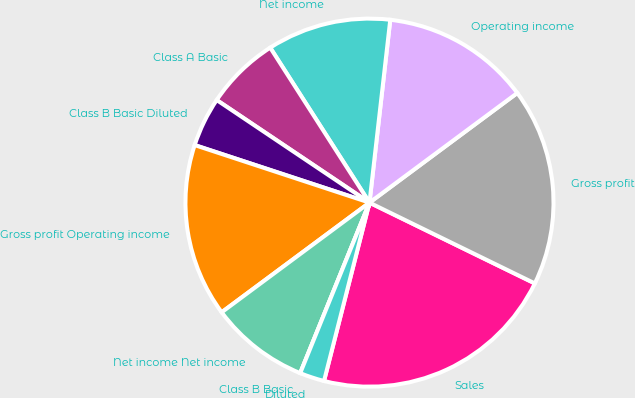Convert chart to OTSL. <chart><loc_0><loc_0><loc_500><loc_500><pie_chart><fcel>Sales<fcel>Gross profit<fcel>Operating income<fcel>Net income<fcel>Class A Basic<fcel>Class B Basic Diluted<fcel>Gross profit Operating income<fcel>Net income Net income<fcel>Class B Basic<fcel>Diluted<nl><fcel>21.74%<fcel>17.39%<fcel>13.04%<fcel>10.87%<fcel>6.52%<fcel>4.35%<fcel>15.22%<fcel>8.7%<fcel>0.0%<fcel>2.17%<nl></chart> 